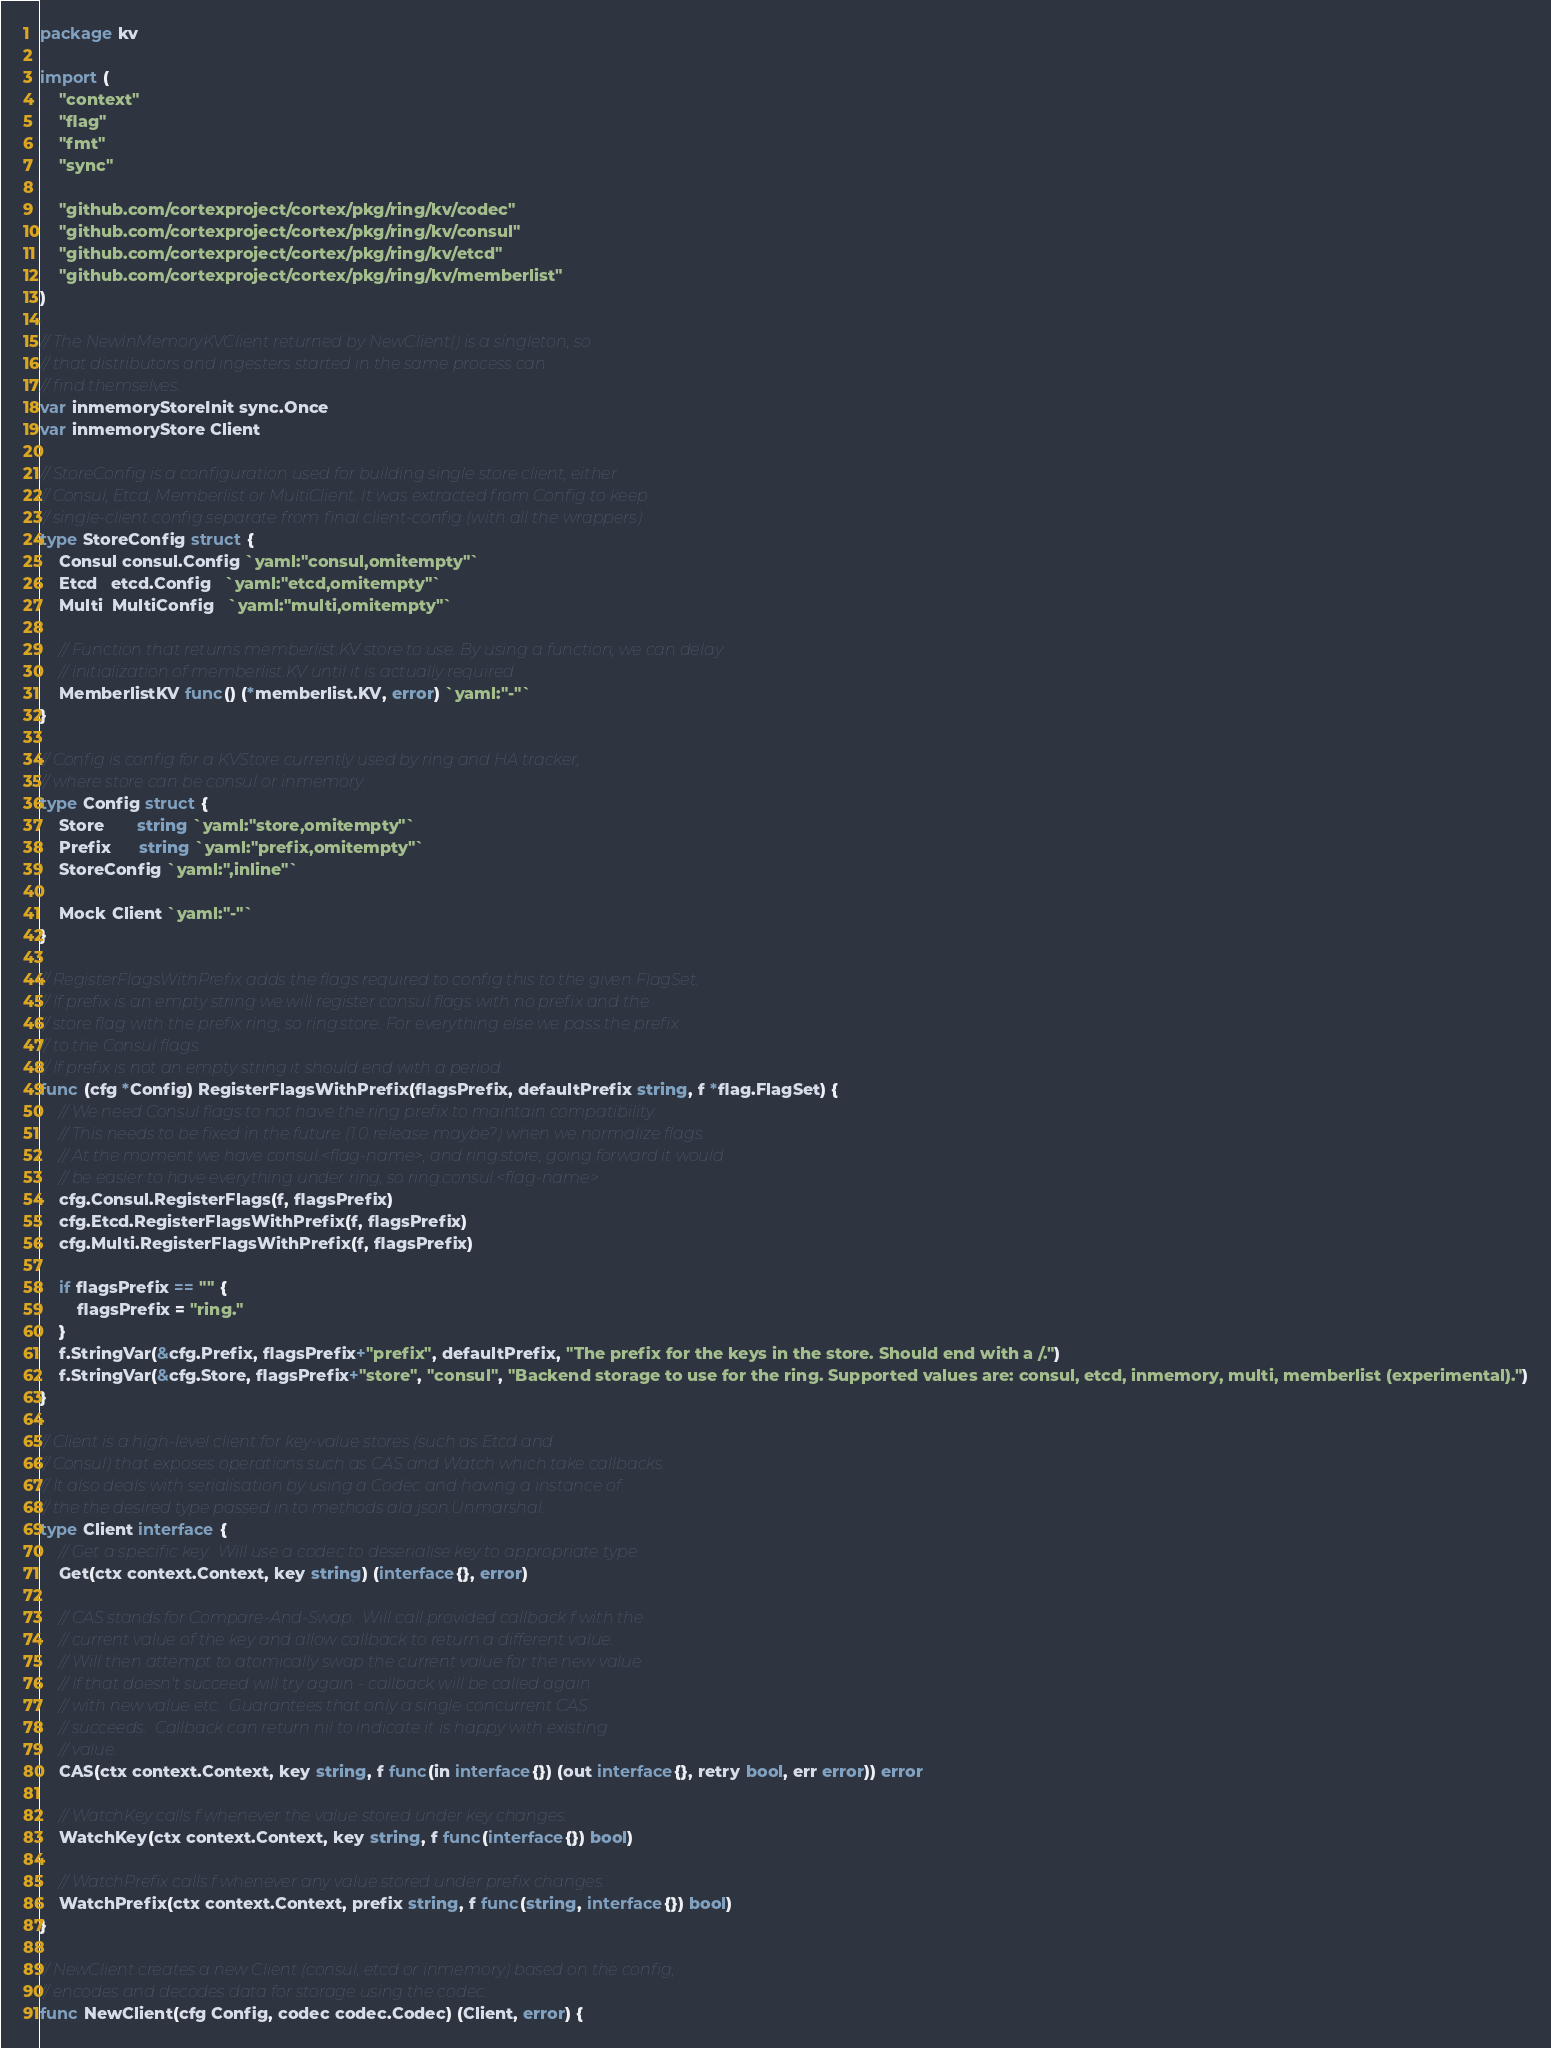<code> <loc_0><loc_0><loc_500><loc_500><_Go_>package kv

import (
	"context"
	"flag"
	"fmt"
	"sync"

	"github.com/cortexproject/cortex/pkg/ring/kv/codec"
	"github.com/cortexproject/cortex/pkg/ring/kv/consul"
	"github.com/cortexproject/cortex/pkg/ring/kv/etcd"
	"github.com/cortexproject/cortex/pkg/ring/kv/memberlist"
)

// The NewInMemoryKVClient returned by NewClient() is a singleton, so
// that distributors and ingesters started in the same process can
// find themselves.
var inmemoryStoreInit sync.Once
var inmemoryStore Client

// StoreConfig is a configuration used for building single store client, either
// Consul, Etcd, Memberlist or MultiClient. It was extracted from Config to keep
// single-client config separate from final client-config (with all the wrappers)
type StoreConfig struct {
	Consul consul.Config `yaml:"consul,omitempty"`
	Etcd   etcd.Config   `yaml:"etcd,omitempty"`
	Multi  MultiConfig   `yaml:"multi,omitempty"`

	// Function that returns memberlist.KV store to use. By using a function, we can delay
	// initialization of memberlist.KV until it is actually required.
	MemberlistKV func() (*memberlist.KV, error) `yaml:"-"`
}

// Config is config for a KVStore currently used by ring and HA tracker,
// where store can be consul or inmemory.
type Config struct {
	Store       string `yaml:"store,omitempty"`
	Prefix      string `yaml:"prefix,omitempty"`
	StoreConfig `yaml:",inline"`

	Mock Client `yaml:"-"`
}

// RegisterFlagsWithPrefix adds the flags required to config this to the given FlagSet.
// If prefix is an empty string we will register consul flags with no prefix and the
// store flag with the prefix ring, so ring.store. For everything else we pass the prefix
// to the Consul flags.
// If prefix is not an empty string it should end with a period.
func (cfg *Config) RegisterFlagsWithPrefix(flagsPrefix, defaultPrefix string, f *flag.FlagSet) {
	// We need Consul flags to not have the ring prefix to maintain compatibility.
	// This needs to be fixed in the future (1.0 release maybe?) when we normalize flags.
	// At the moment we have consul.<flag-name>, and ring.store, going forward it would
	// be easier to have everything under ring, so ring.consul.<flag-name>
	cfg.Consul.RegisterFlags(f, flagsPrefix)
	cfg.Etcd.RegisterFlagsWithPrefix(f, flagsPrefix)
	cfg.Multi.RegisterFlagsWithPrefix(f, flagsPrefix)

	if flagsPrefix == "" {
		flagsPrefix = "ring."
	}
	f.StringVar(&cfg.Prefix, flagsPrefix+"prefix", defaultPrefix, "The prefix for the keys in the store. Should end with a /.")
	f.StringVar(&cfg.Store, flagsPrefix+"store", "consul", "Backend storage to use for the ring. Supported values are: consul, etcd, inmemory, multi, memberlist (experimental).")
}

// Client is a high-level client for key-value stores (such as Etcd and
// Consul) that exposes operations such as CAS and Watch which take callbacks.
// It also deals with serialisation by using a Codec and having a instance of
// the the desired type passed in to methods ala json.Unmarshal.
type Client interface {
	// Get a specific key.  Will use a codec to deserialise key to appropriate type.
	Get(ctx context.Context, key string) (interface{}, error)

	// CAS stands for Compare-And-Swap.  Will call provided callback f with the
	// current value of the key and allow callback to return a different value.
	// Will then attempt to atomically swap the current value for the new value.
	// If that doesn't succeed will try again - callback will be called again
	// with new value etc.  Guarantees that only a single concurrent CAS
	// succeeds.  Callback can return nil to indicate it is happy with existing
	// value.
	CAS(ctx context.Context, key string, f func(in interface{}) (out interface{}, retry bool, err error)) error

	// WatchKey calls f whenever the value stored under key changes.
	WatchKey(ctx context.Context, key string, f func(interface{}) bool)

	// WatchPrefix calls f whenever any value stored under prefix changes.
	WatchPrefix(ctx context.Context, prefix string, f func(string, interface{}) bool)
}

// NewClient creates a new Client (consul, etcd or inmemory) based on the config,
// encodes and decodes data for storage using the codec.
func NewClient(cfg Config, codec codec.Codec) (Client, error) {</code> 